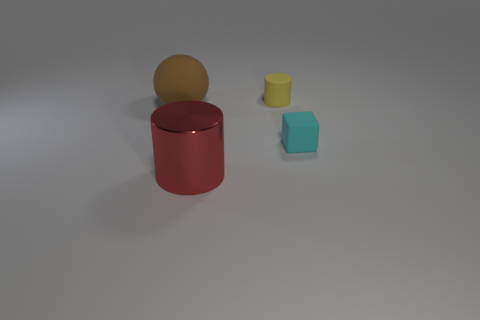Is there a tiny cyan thing in front of the small cyan matte thing that is behind the cylinder in front of the cube?
Offer a very short reply. No. Are there any purple balls of the same size as the yellow thing?
Provide a succinct answer. No. What is the material of the other thing that is the same size as the brown rubber thing?
Your answer should be very brief. Metal. There is a yellow thing; does it have the same size as the red metallic cylinder that is in front of the cyan thing?
Provide a short and direct response. No. How many shiny objects are either brown spheres or large yellow balls?
Your answer should be very brief. 0. How many tiny red matte objects have the same shape as the yellow rubber object?
Your answer should be very brief. 0. Do the rubber object that is in front of the large sphere and the matte thing that is on the left side of the yellow cylinder have the same size?
Your answer should be very brief. No. There is a thing in front of the cyan thing; what is its shape?
Your answer should be very brief. Cylinder. There is another tiny object that is the same shape as the red object; what material is it?
Make the answer very short. Rubber. There is a object that is on the left side of the red object; is its size the same as the small matte cylinder?
Your answer should be very brief. No. 